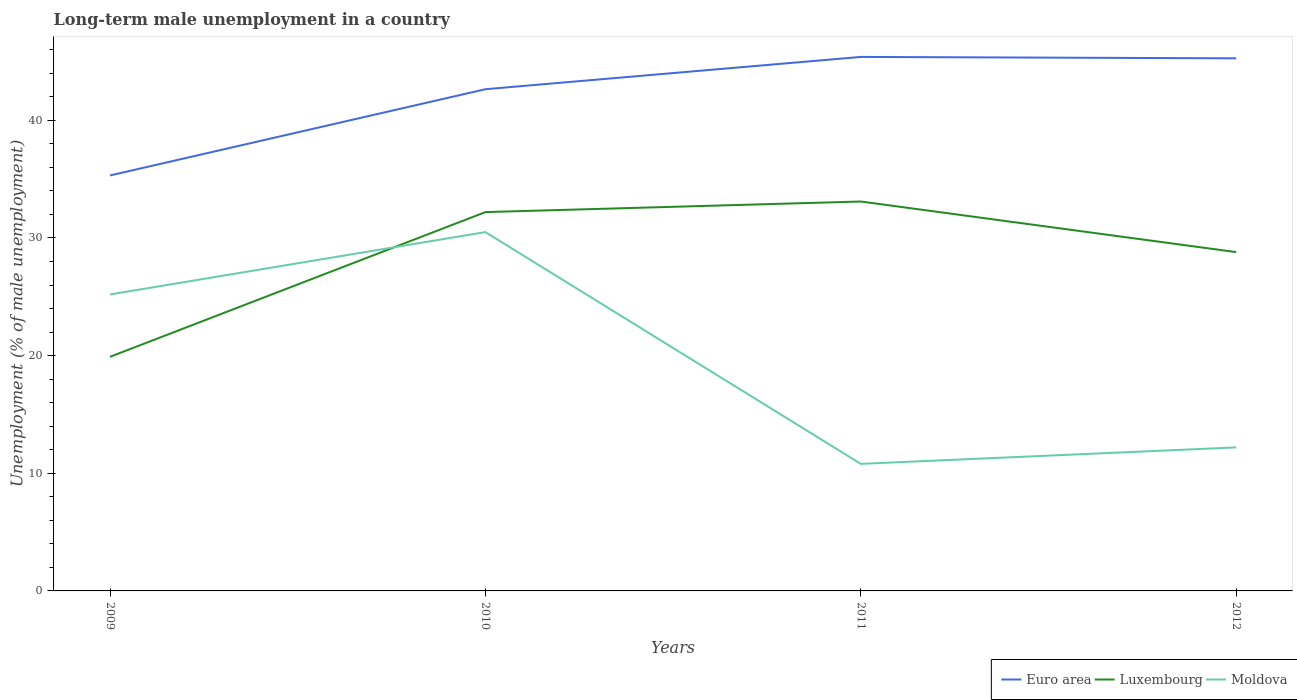How many different coloured lines are there?
Make the answer very short. 3. Across all years, what is the maximum percentage of long-term unemployed male population in Luxembourg?
Make the answer very short. 19.9. What is the total percentage of long-term unemployed male population in Luxembourg in the graph?
Keep it short and to the point. -8.9. What is the difference between the highest and the second highest percentage of long-term unemployed male population in Euro area?
Provide a short and direct response. 10.07. How many years are there in the graph?
Provide a short and direct response. 4. Does the graph contain any zero values?
Keep it short and to the point. No. How many legend labels are there?
Provide a short and direct response. 3. What is the title of the graph?
Ensure brevity in your answer.  Long-term male unemployment in a country. What is the label or title of the Y-axis?
Provide a short and direct response. Unemployment (% of male unemployment). What is the Unemployment (% of male unemployment) in Euro area in 2009?
Offer a very short reply. 35.32. What is the Unemployment (% of male unemployment) in Luxembourg in 2009?
Offer a very short reply. 19.9. What is the Unemployment (% of male unemployment) of Moldova in 2009?
Your response must be concise. 25.2. What is the Unemployment (% of male unemployment) of Euro area in 2010?
Provide a succinct answer. 42.65. What is the Unemployment (% of male unemployment) of Luxembourg in 2010?
Your response must be concise. 32.2. What is the Unemployment (% of male unemployment) in Moldova in 2010?
Your answer should be very brief. 30.5. What is the Unemployment (% of male unemployment) in Euro area in 2011?
Give a very brief answer. 45.39. What is the Unemployment (% of male unemployment) in Luxembourg in 2011?
Your answer should be very brief. 33.1. What is the Unemployment (% of male unemployment) of Moldova in 2011?
Provide a succinct answer. 10.8. What is the Unemployment (% of male unemployment) of Euro area in 2012?
Offer a terse response. 45.27. What is the Unemployment (% of male unemployment) in Luxembourg in 2012?
Your answer should be compact. 28.8. What is the Unemployment (% of male unemployment) in Moldova in 2012?
Offer a terse response. 12.2. Across all years, what is the maximum Unemployment (% of male unemployment) in Euro area?
Ensure brevity in your answer.  45.39. Across all years, what is the maximum Unemployment (% of male unemployment) of Luxembourg?
Provide a short and direct response. 33.1. Across all years, what is the maximum Unemployment (% of male unemployment) of Moldova?
Make the answer very short. 30.5. Across all years, what is the minimum Unemployment (% of male unemployment) in Euro area?
Your answer should be compact. 35.32. Across all years, what is the minimum Unemployment (% of male unemployment) of Luxembourg?
Your answer should be very brief. 19.9. Across all years, what is the minimum Unemployment (% of male unemployment) of Moldova?
Your answer should be very brief. 10.8. What is the total Unemployment (% of male unemployment) in Euro area in the graph?
Ensure brevity in your answer.  168.62. What is the total Unemployment (% of male unemployment) in Luxembourg in the graph?
Provide a succinct answer. 114. What is the total Unemployment (% of male unemployment) in Moldova in the graph?
Give a very brief answer. 78.7. What is the difference between the Unemployment (% of male unemployment) in Euro area in 2009 and that in 2010?
Your answer should be very brief. -7.33. What is the difference between the Unemployment (% of male unemployment) in Luxembourg in 2009 and that in 2010?
Your answer should be very brief. -12.3. What is the difference between the Unemployment (% of male unemployment) of Euro area in 2009 and that in 2011?
Your answer should be very brief. -10.07. What is the difference between the Unemployment (% of male unemployment) of Moldova in 2009 and that in 2011?
Provide a short and direct response. 14.4. What is the difference between the Unemployment (% of male unemployment) of Euro area in 2009 and that in 2012?
Keep it short and to the point. -9.96. What is the difference between the Unemployment (% of male unemployment) in Moldova in 2009 and that in 2012?
Your answer should be compact. 13. What is the difference between the Unemployment (% of male unemployment) of Euro area in 2010 and that in 2011?
Offer a very short reply. -2.74. What is the difference between the Unemployment (% of male unemployment) in Moldova in 2010 and that in 2011?
Your answer should be compact. 19.7. What is the difference between the Unemployment (% of male unemployment) in Euro area in 2010 and that in 2012?
Offer a very short reply. -2.63. What is the difference between the Unemployment (% of male unemployment) in Euro area in 2011 and that in 2012?
Keep it short and to the point. 0.12. What is the difference between the Unemployment (% of male unemployment) of Luxembourg in 2011 and that in 2012?
Give a very brief answer. 4.3. What is the difference between the Unemployment (% of male unemployment) of Euro area in 2009 and the Unemployment (% of male unemployment) of Luxembourg in 2010?
Offer a terse response. 3.12. What is the difference between the Unemployment (% of male unemployment) of Euro area in 2009 and the Unemployment (% of male unemployment) of Moldova in 2010?
Offer a very short reply. 4.82. What is the difference between the Unemployment (% of male unemployment) of Luxembourg in 2009 and the Unemployment (% of male unemployment) of Moldova in 2010?
Provide a short and direct response. -10.6. What is the difference between the Unemployment (% of male unemployment) in Euro area in 2009 and the Unemployment (% of male unemployment) in Luxembourg in 2011?
Offer a terse response. 2.22. What is the difference between the Unemployment (% of male unemployment) of Euro area in 2009 and the Unemployment (% of male unemployment) of Moldova in 2011?
Ensure brevity in your answer.  24.52. What is the difference between the Unemployment (% of male unemployment) of Luxembourg in 2009 and the Unemployment (% of male unemployment) of Moldova in 2011?
Make the answer very short. 9.1. What is the difference between the Unemployment (% of male unemployment) of Euro area in 2009 and the Unemployment (% of male unemployment) of Luxembourg in 2012?
Provide a succinct answer. 6.52. What is the difference between the Unemployment (% of male unemployment) in Euro area in 2009 and the Unemployment (% of male unemployment) in Moldova in 2012?
Provide a succinct answer. 23.12. What is the difference between the Unemployment (% of male unemployment) in Euro area in 2010 and the Unemployment (% of male unemployment) in Luxembourg in 2011?
Offer a very short reply. 9.55. What is the difference between the Unemployment (% of male unemployment) of Euro area in 2010 and the Unemployment (% of male unemployment) of Moldova in 2011?
Ensure brevity in your answer.  31.85. What is the difference between the Unemployment (% of male unemployment) of Luxembourg in 2010 and the Unemployment (% of male unemployment) of Moldova in 2011?
Ensure brevity in your answer.  21.4. What is the difference between the Unemployment (% of male unemployment) of Euro area in 2010 and the Unemployment (% of male unemployment) of Luxembourg in 2012?
Keep it short and to the point. 13.85. What is the difference between the Unemployment (% of male unemployment) in Euro area in 2010 and the Unemployment (% of male unemployment) in Moldova in 2012?
Your answer should be compact. 30.45. What is the difference between the Unemployment (% of male unemployment) of Euro area in 2011 and the Unemployment (% of male unemployment) of Luxembourg in 2012?
Ensure brevity in your answer.  16.59. What is the difference between the Unemployment (% of male unemployment) of Euro area in 2011 and the Unemployment (% of male unemployment) of Moldova in 2012?
Your answer should be very brief. 33.19. What is the difference between the Unemployment (% of male unemployment) of Luxembourg in 2011 and the Unemployment (% of male unemployment) of Moldova in 2012?
Your response must be concise. 20.9. What is the average Unemployment (% of male unemployment) in Euro area per year?
Ensure brevity in your answer.  42.16. What is the average Unemployment (% of male unemployment) of Moldova per year?
Your answer should be compact. 19.68. In the year 2009, what is the difference between the Unemployment (% of male unemployment) in Euro area and Unemployment (% of male unemployment) in Luxembourg?
Provide a short and direct response. 15.42. In the year 2009, what is the difference between the Unemployment (% of male unemployment) in Euro area and Unemployment (% of male unemployment) in Moldova?
Ensure brevity in your answer.  10.12. In the year 2009, what is the difference between the Unemployment (% of male unemployment) of Luxembourg and Unemployment (% of male unemployment) of Moldova?
Offer a very short reply. -5.3. In the year 2010, what is the difference between the Unemployment (% of male unemployment) of Euro area and Unemployment (% of male unemployment) of Luxembourg?
Offer a terse response. 10.45. In the year 2010, what is the difference between the Unemployment (% of male unemployment) in Euro area and Unemployment (% of male unemployment) in Moldova?
Keep it short and to the point. 12.15. In the year 2011, what is the difference between the Unemployment (% of male unemployment) in Euro area and Unemployment (% of male unemployment) in Luxembourg?
Keep it short and to the point. 12.29. In the year 2011, what is the difference between the Unemployment (% of male unemployment) of Euro area and Unemployment (% of male unemployment) of Moldova?
Your answer should be compact. 34.59. In the year 2011, what is the difference between the Unemployment (% of male unemployment) in Luxembourg and Unemployment (% of male unemployment) in Moldova?
Provide a short and direct response. 22.3. In the year 2012, what is the difference between the Unemployment (% of male unemployment) in Euro area and Unemployment (% of male unemployment) in Luxembourg?
Offer a very short reply. 16.47. In the year 2012, what is the difference between the Unemployment (% of male unemployment) of Euro area and Unemployment (% of male unemployment) of Moldova?
Offer a very short reply. 33.07. What is the ratio of the Unemployment (% of male unemployment) in Euro area in 2009 to that in 2010?
Make the answer very short. 0.83. What is the ratio of the Unemployment (% of male unemployment) of Luxembourg in 2009 to that in 2010?
Ensure brevity in your answer.  0.62. What is the ratio of the Unemployment (% of male unemployment) in Moldova in 2009 to that in 2010?
Your answer should be compact. 0.83. What is the ratio of the Unemployment (% of male unemployment) of Euro area in 2009 to that in 2011?
Give a very brief answer. 0.78. What is the ratio of the Unemployment (% of male unemployment) in Luxembourg in 2009 to that in 2011?
Offer a terse response. 0.6. What is the ratio of the Unemployment (% of male unemployment) of Moldova in 2009 to that in 2011?
Provide a succinct answer. 2.33. What is the ratio of the Unemployment (% of male unemployment) of Euro area in 2009 to that in 2012?
Keep it short and to the point. 0.78. What is the ratio of the Unemployment (% of male unemployment) of Luxembourg in 2009 to that in 2012?
Provide a short and direct response. 0.69. What is the ratio of the Unemployment (% of male unemployment) in Moldova in 2009 to that in 2012?
Make the answer very short. 2.07. What is the ratio of the Unemployment (% of male unemployment) in Euro area in 2010 to that in 2011?
Your response must be concise. 0.94. What is the ratio of the Unemployment (% of male unemployment) in Luxembourg in 2010 to that in 2011?
Give a very brief answer. 0.97. What is the ratio of the Unemployment (% of male unemployment) in Moldova in 2010 to that in 2011?
Offer a very short reply. 2.82. What is the ratio of the Unemployment (% of male unemployment) in Euro area in 2010 to that in 2012?
Ensure brevity in your answer.  0.94. What is the ratio of the Unemployment (% of male unemployment) of Luxembourg in 2010 to that in 2012?
Keep it short and to the point. 1.12. What is the ratio of the Unemployment (% of male unemployment) in Moldova in 2010 to that in 2012?
Give a very brief answer. 2.5. What is the ratio of the Unemployment (% of male unemployment) of Euro area in 2011 to that in 2012?
Offer a very short reply. 1. What is the ratio of the Unemployment (% of male unemployment) of Luxembourg in 2011 to that in 2012?
Offer a terse response. 1.15. What is the ratio of the Unemployment (% of male unemployment) of Moldova in 2011 to that in 2012?
Offer a very short reply. 0.89. What is the difference between the highest and the second highest Unemployment (% of male unemployment) of Euro area?
Offer a very short reply. 0.12. What is the difference between the highest and the second highest Unemployment (% of male unemployment) of Luxembourg?
Give a very brief answer. 0.9. What is the difference between the highest and the lowest Unemployment (% of male unemployment) of Euro area?
Ensure brevity in your answer.  10.07. What is the difference between the highest and the lowest Unemployment (% of male unemployment) in Moldova?
Your answer should be compact. 19.7. 